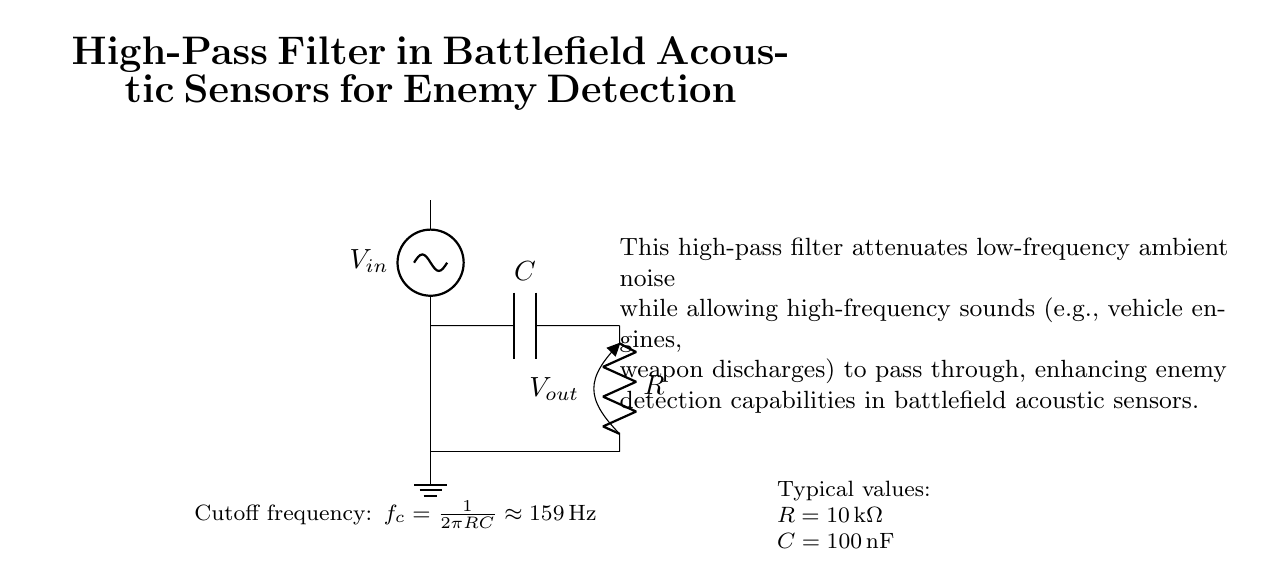What type of filter is shown in the circuit? The circuit shows a high-pass filter, as indicated in the title and by the arrangement of the components which allows high-frequency signals to pass while attenuating low frequencies.
Answer: High-pass filter What is the role of the capacitor in this circuit? The capacitor in a high-pass filter blocks low-frequency signals, allowing higher frequencies to pass through to the output, which is essential for detecting sounds like vehicle engines and weapon discharges in battlefield scenarios.
Answer: Blocks low frequencies What is the resistance value used in the circuit? The resistance value mentioned in the diagram is ten thousand ohms (10 kΩ), as noted under the typical values section in the circuit description.
Answer: Ten thousand ohms What is the cutoff frequency of this high-pass filter? The cutoff frequency is calculated using the formula f_c = 1/(2πRC), which gives approximately one hundred fifty-nine hertz (159 Hz) for the provided values of R and C.
Answer: One hundred fifty-nine hertz What happens to ambient noise in this circuit? The ambient noise, particularly low-frequency noise, is attenuated by the high-pass filter, which enhances the ability to detect higher-frequency sounds relevant in a battlefield situation.
Answer: Attenuated Which components are primarily involved in determining the cutoff frequency? The cutoff frequency depends primarily on the values of the resistor and the capacitor; in this case, the ten thousand ohms resistor and the one hundred nanofarads capacitor define it.
Answer: Resistor and capacitor 